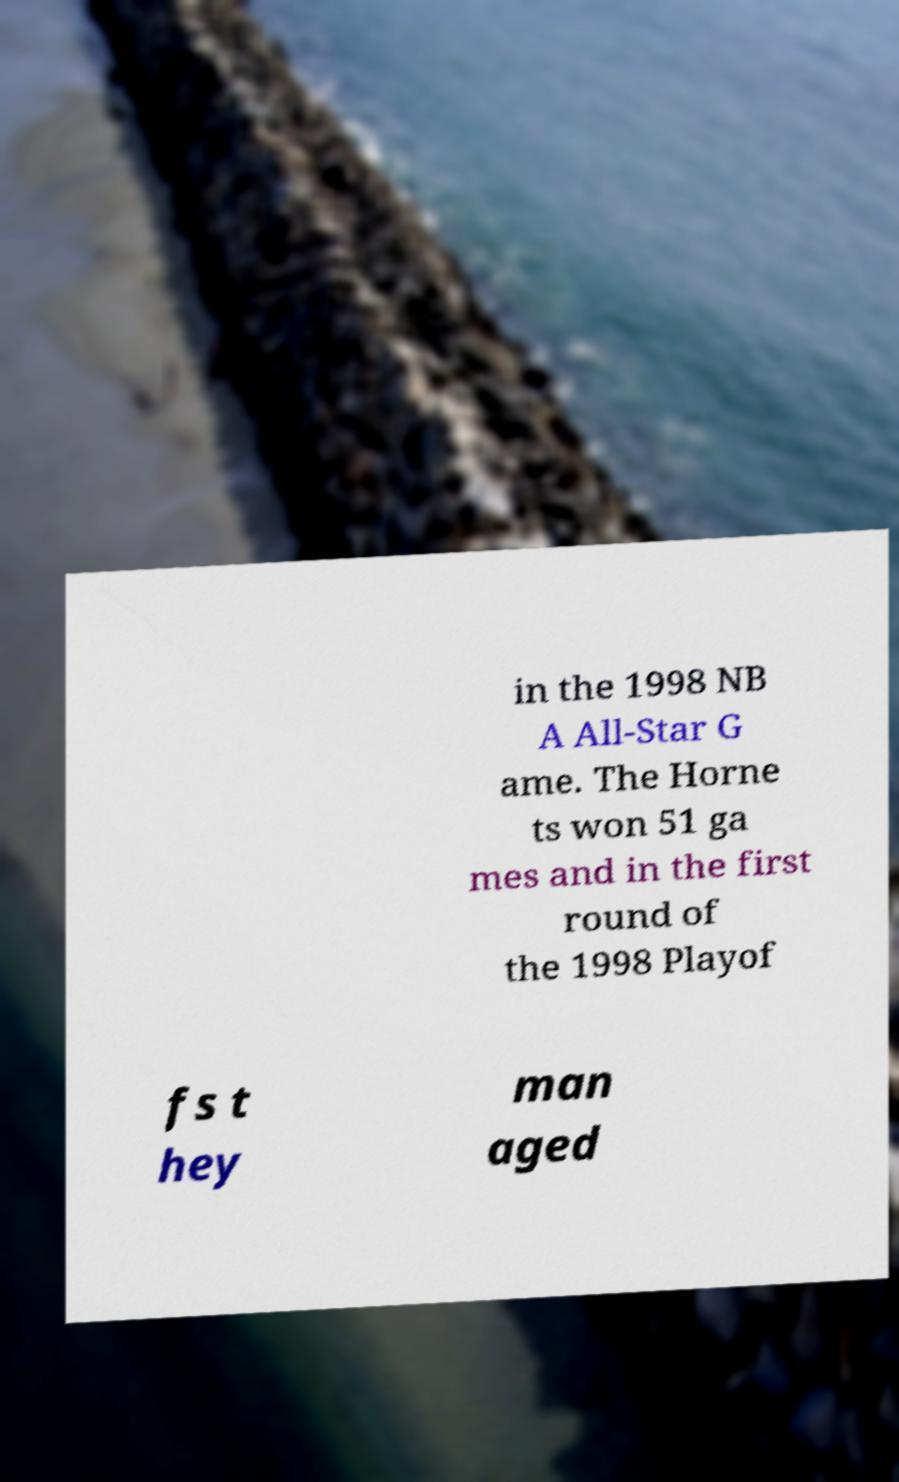What messages or text are displayed in this image? I need them in a readable, typed format. in the 1998 NB A All-Star G ame. The Horne ts won 51 ga mes and in the first round of the 1998 Playof fs t hey man aged 